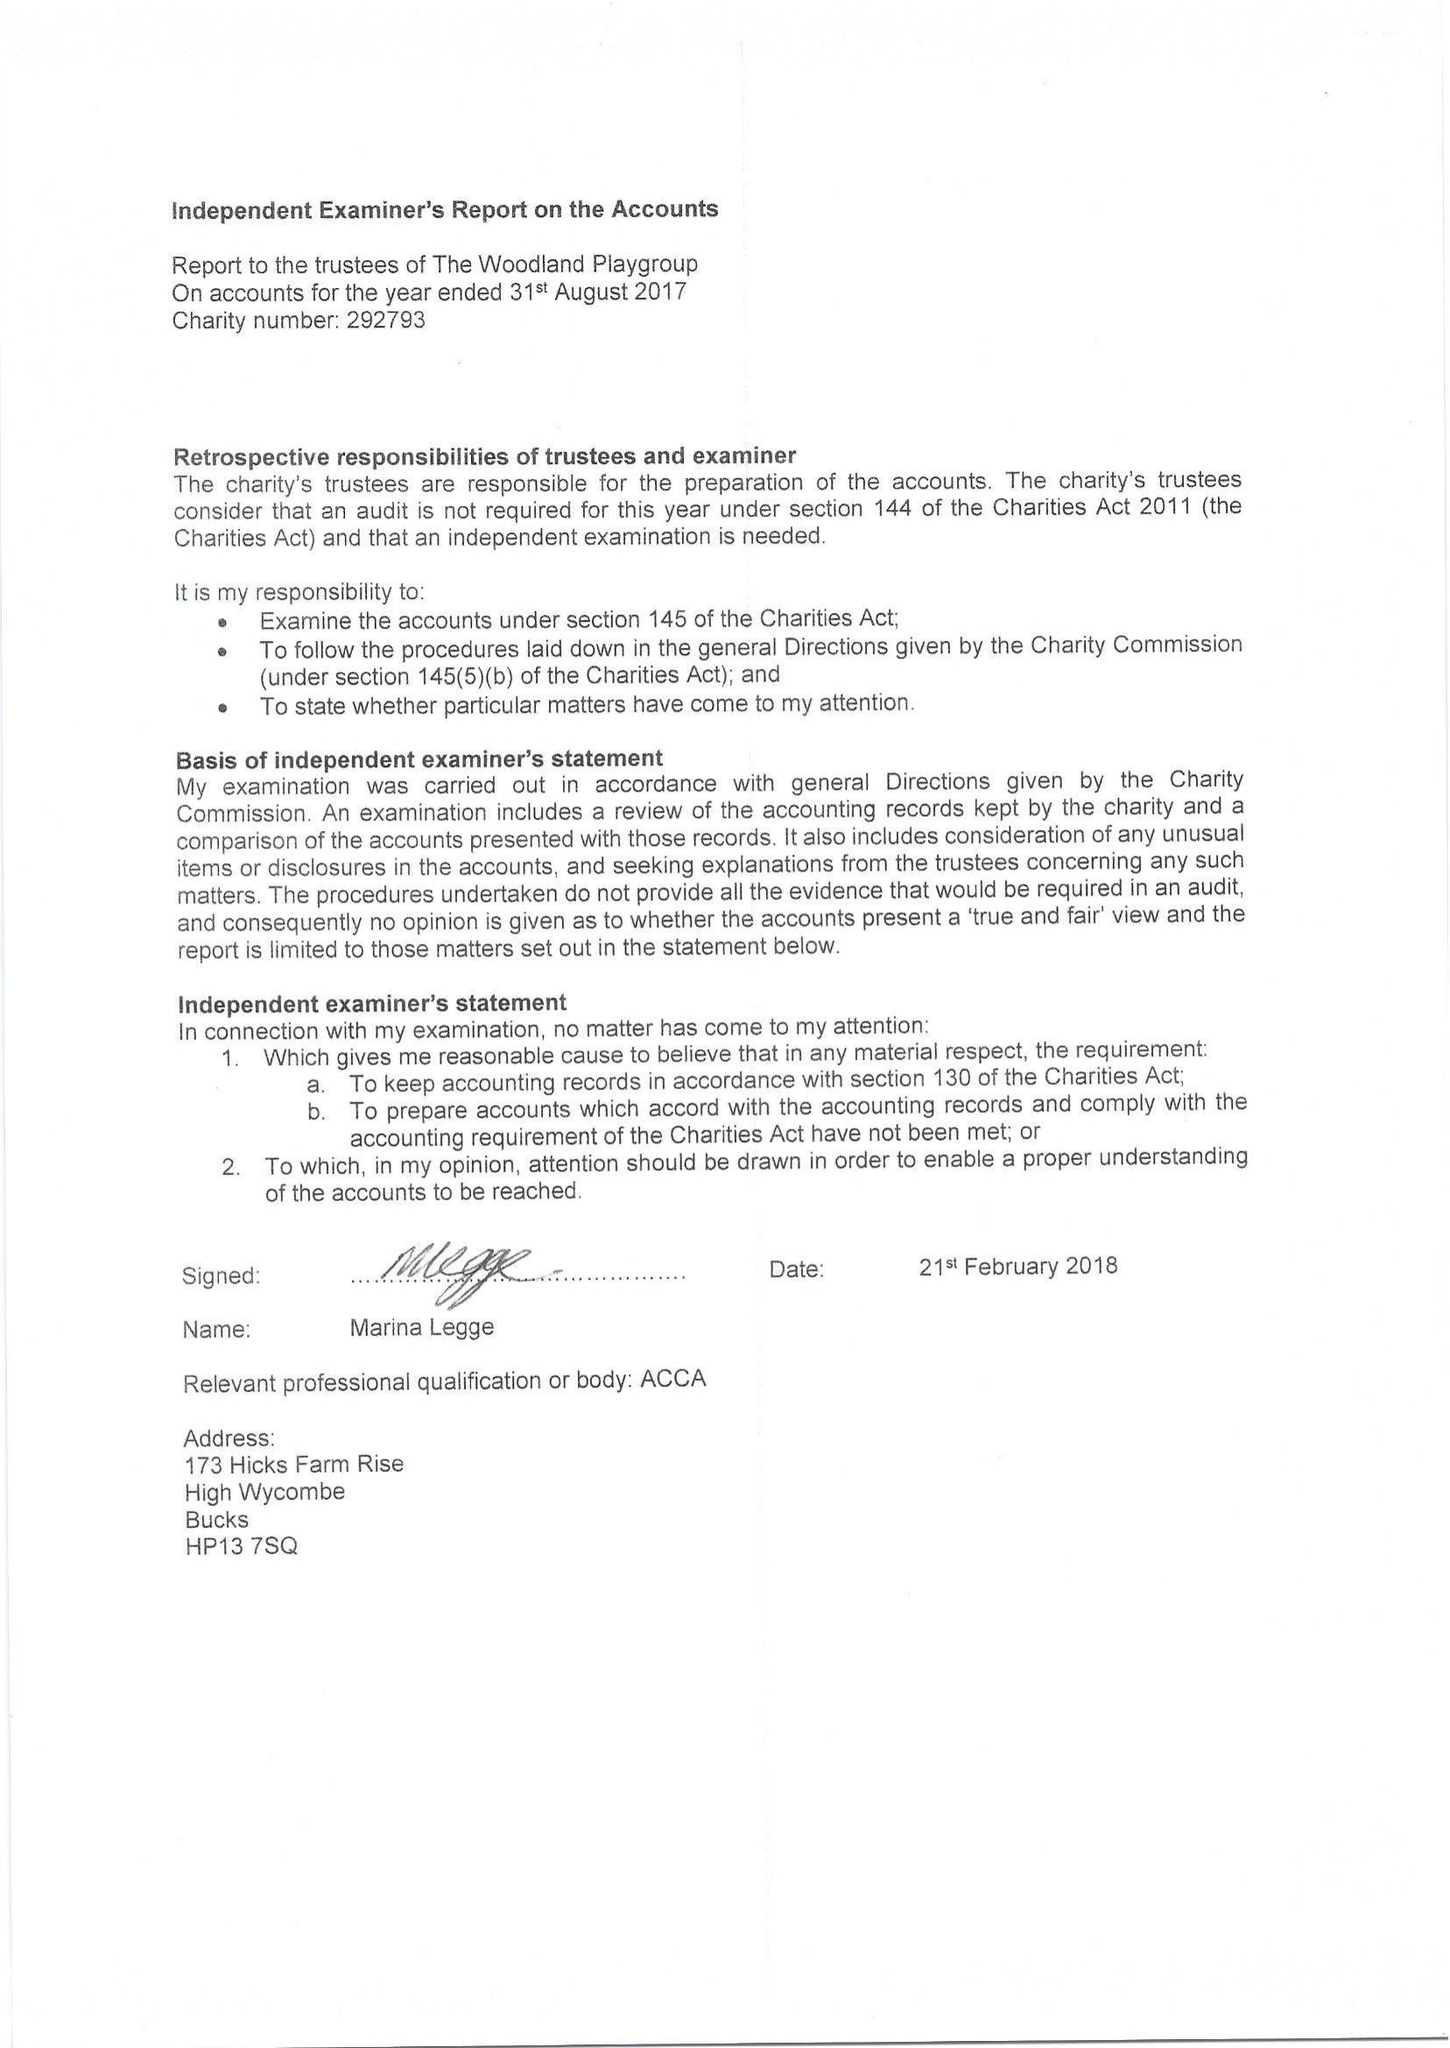What is the value for the address__post_town?
Answer the question using a single word or phrase. HIGH WYCOMBE 